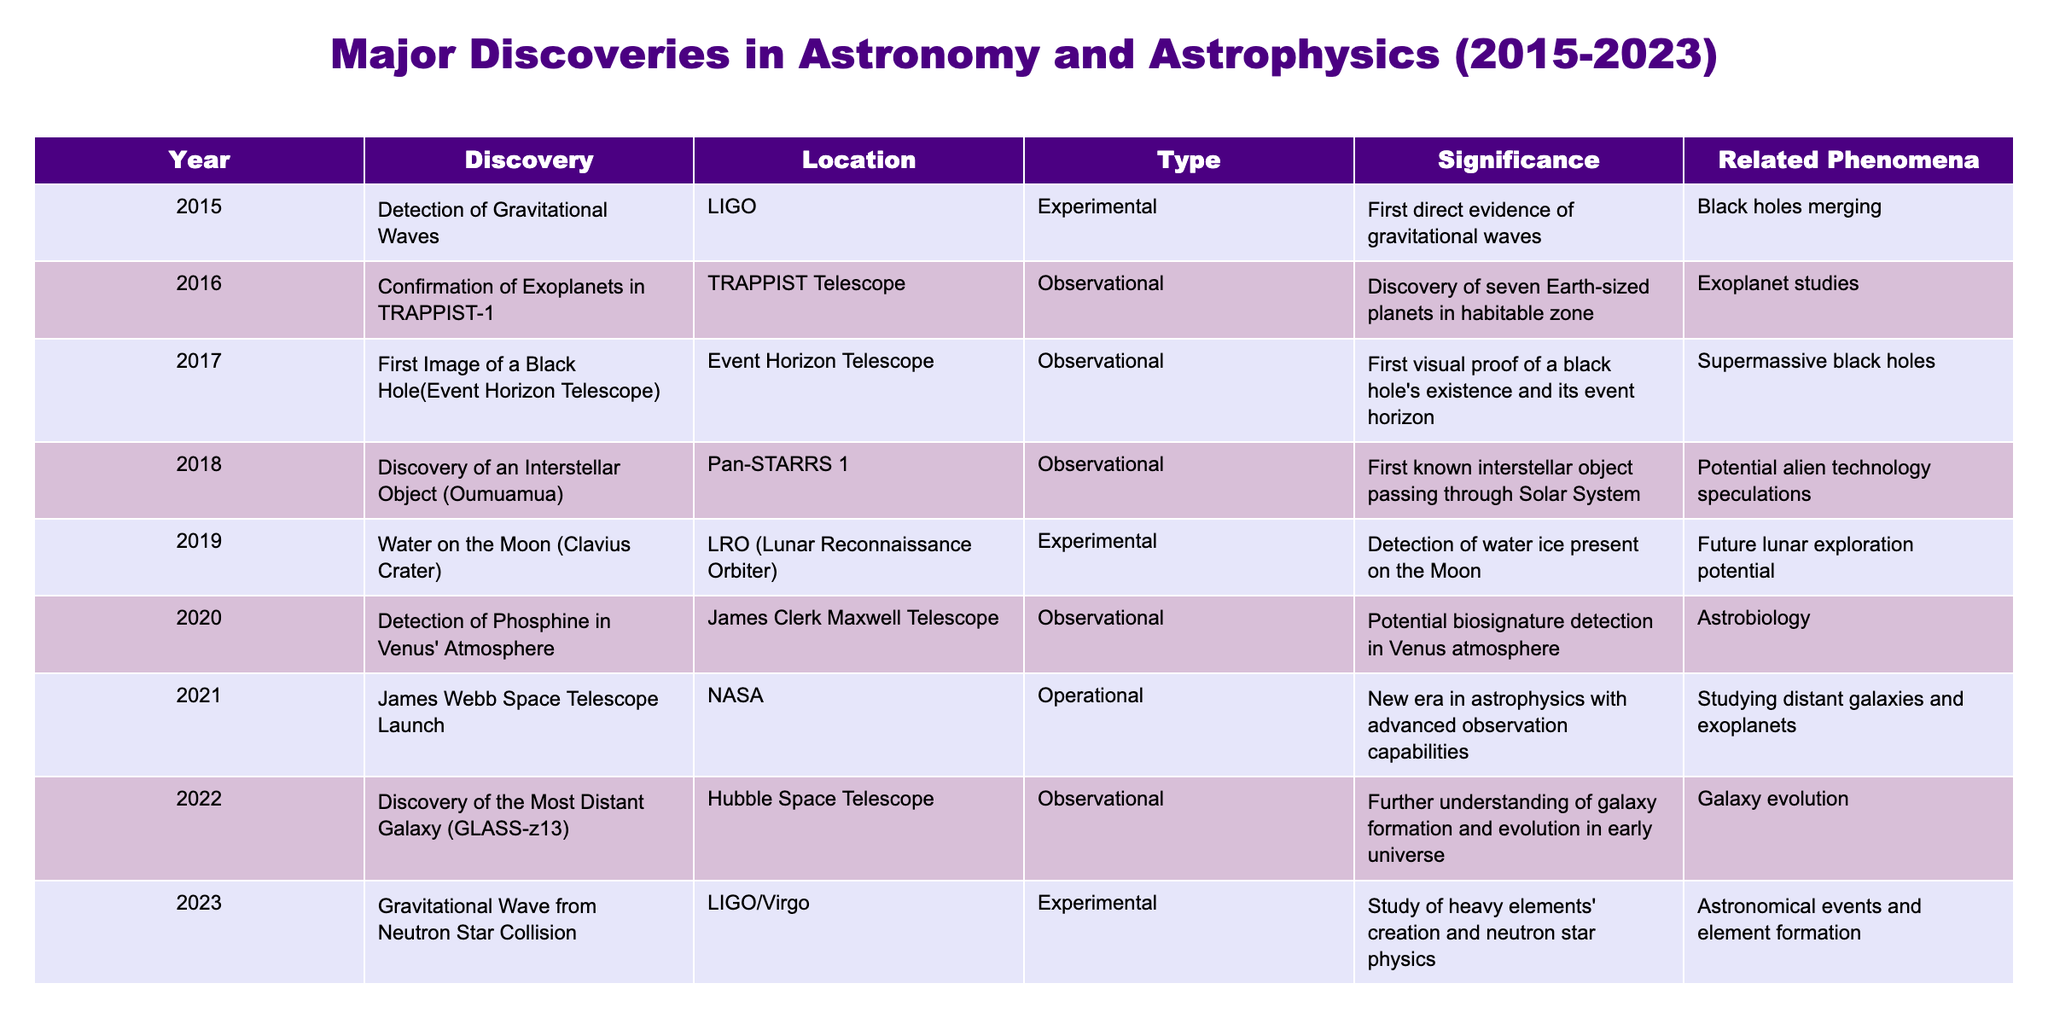What major discovery occurred in 2018? From the table, I can see that the discovery of an interstellar object named Oumuamua was made in 2018.
Answer: Discovery of an interstellar object (Oumuamua) Which year did the James Webb Space Telescope launch? By looking at the table, the launch of the James Webb Space Telescope occurred in 2021.
Answer: 2021 How many discoveries were made in 2019? The table shows that there was one discovery in 2019, which is the detection of water on the Moon.
Answer: One What type of discovery was the confirmation of exoplanets in TRAPPIST-1? The table indicates that the confirmation of exoplanets in TRAPPIST-1 was an observational type of discovery.
Answer: Observational How many of the discoveries are observational? From the table, I count 5 observational discoveries: TRAPPIST-1, black hole image, Oumuamua, phosphine in Venus, and distant galaxy.
Answer: Five Did the detection of gravitational waves provide direct evidence? Yes, the table states that the detection of gravitational waves in 2015 provided the first direct evidence.
Answer: Yes What is the significance of the discovery in 2023? The significance of the gravitational wave from the neutron star collision in 2023 is the study of heavy elements' creation and neutron star physics, according to the table.
Answer: Study of heavy elements' creation Which discovery has the relationship with potential alien technology? Referring to the table, the discovery of the interstellar object Oumuamua in 2018 relates to potential alien technology speculations.
Answer: Discovery of an interstellar object (Oumuamua) Which year had the fewest discoveries listed? Looking through the years in the table, 2015 had the fewest discoveries listed, with only one.
Answer: 2015 What was the first direct evidence of gravitational waves? The detection of gravitational waves in 2015 provided the first direct evidence, as per the information in the table.
Answer: Detection of gravitational waves What phenomenon relates to the discovery made in 2022? The discovery of the most distant galaxy in 2022 relates to galaxy evolution, as specified in the table.
Answer: Galaxy evolution How does the number of discoveries in 2020 compare to those in 2021? The table shows one discovery in 2020 and one in 2021. Therefore, they are equal in number.
Answer: Equal What was the last astronomical event mentioned in the table? The last astronomical event mentioned is the gravitational wave from a neutron star collision in 2023.
Answer: Gravitational wave from neutron star collision Which discovery aimed to advance future lunar exploration? The detection of water ice on the Moon in the Clavius Crater aimed at future lunar exploration, as detailed in the table.
Answer: Detection of water on the Moon Had any discoveries been made related to astrobiology? Yes, the detection of phosphine in Venus' atmosphere in 2020 is related to astrobiology, according to the table.
Answer: Yes What can we infer about the trend of discoveries from 2015 to 2023? By examining the table, we can see a steady progression of important discoveries each year, suggesting active research in astronomy and astrophysics.
Answer: Steady progression of discoveries 